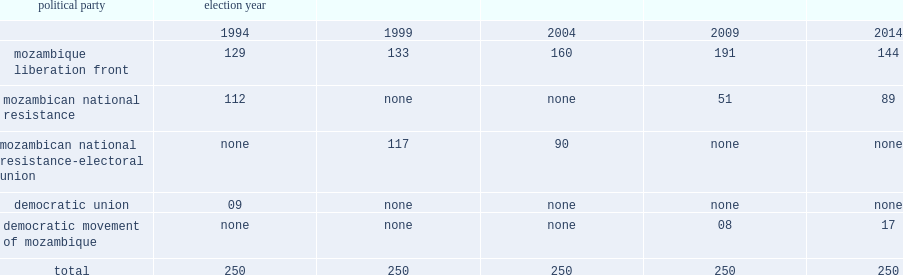How many seats did the mozambican national resistance-electoral union (renamo-ue) win? 117.0. 